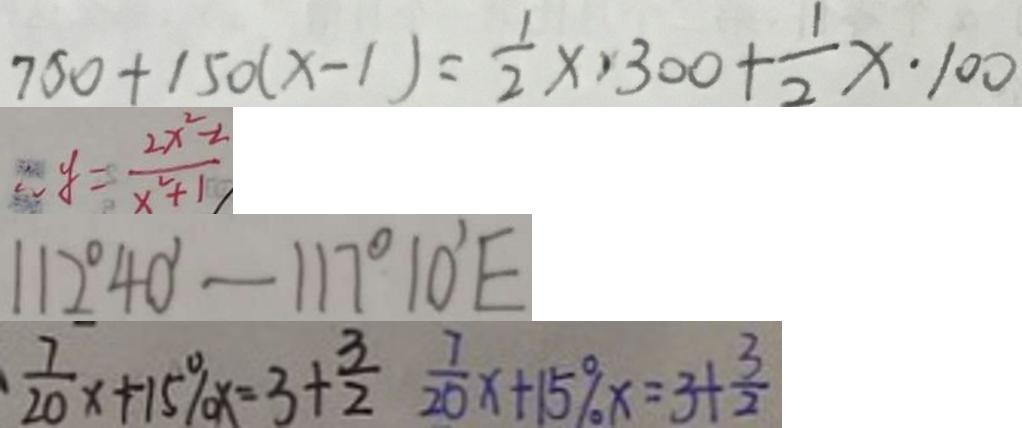<formula> <loc_0><loc_0><loc_500><loc_500>7 5 0 + 1 5 0 ( x - 1 ) = \frac { 1 } { 2 } \times 3 0 0 + \frac { 1 } { 2 } x \cdot 1 0 0 
 \therefore y = \frac { 2 x ^ { 2 } - 2 } { x ^ { 2 } + 1 } 
 1 1 2 ^ { \circ } 4 0 ^ { \prime } - 1 1 7 ^ { \circ } 1 0 ^ { \prime } E 
 \frac { 7 } { 2 0 } x + 1 5 \% x = 3 + \frac { 3 } { 2 } \frac { 7 } { 2 0 } x + 1 5 \% x = 3 + \frac { 3 } { 2 }</formula> 